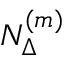<formula> <loc_0><loc_0><loc_500><loc_500>N _ { \Delta } ^ { ( m ) }</formula> 